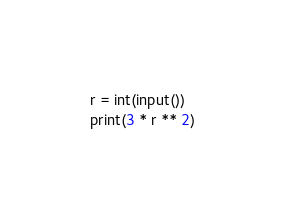Convert code to text. <code><loc_0><loc_0><loc_500><loc_500><_Python_>r = int(input())
print(3 * r ** 2)
</code> 